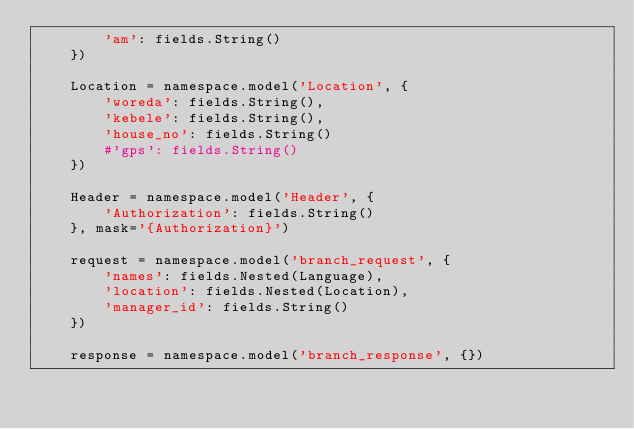Convert code to text. <code><loc_0><loc_0><loc_500><loc_500><_Python_>        'am': fields.String()
    })

    Location = namespace.model('Location', {
        'woreda': fields.String(),
        'kebele': fields.String(),
        'house_no': fields.String()
        #'gps': fields.String()
    })

    Header = namespace.model('Header', {
        'Authorization': fields.String()
    }, mask='{Authorization}') 

    request = namespace.model('branch_request', {
        'names': fields.Nested(Language),
        'location': fields.Nested(Location),
        'manager_id': fields.String()
    })

    response = namespace.model('branch_response', {})</code> 